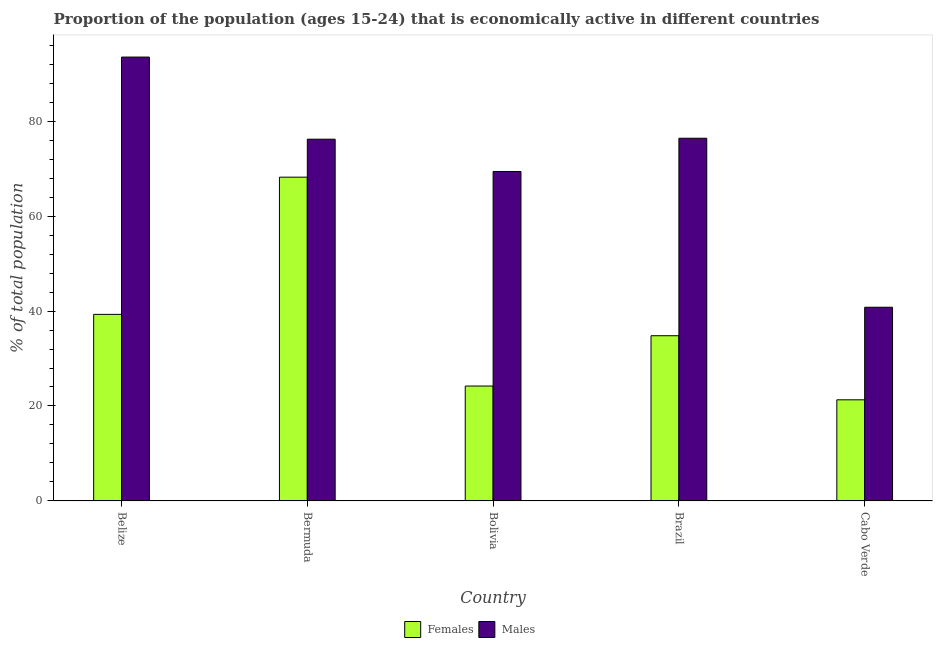What is the label of the 3rd group of bars from the left?
Your answer should be compact. Bolivia. In how many cases, is the number of bars for a given country not equal to the number of legend labels?
Give a very brief answer. 0. What is the percentage of economically active female population in Bermuda?
Make the answer very short. 68.2. Across all countries, what is the maximum percentage of economically active male population?
Make the answer very short. 93.5. Across all countries, what is the minimum percentage of economically active female population?
Make the answer very short. 21.3. In which country was the percentage of economically active female population maximum?
Offer a very short reply. Bermuda. In which country was the percentage of economically active female population minimum?
Your response must be concise. Cabo Verde. What is the total percentage of economically active female population in the graph?
Provide a short and direct response. 187.8. What is the difference between the percentage of economically active female population in Bolivia and the percentage of economically active male population in Belize?
Your answer should be compact. -69.3. What is the average percentage of economically active female population per country?
Offer a terse response. 37.56. What is the difference between the percentage of economically active female population and percentage of economically active male population in Belize?
Offer a terse response. -54.2. What is the ratio of the percentage of economically active female population in Belize to that in Cabo Verde?
Ensure brevity in your answer.  1.85. Is the percentage of economically active male population in Bolivia less than that in Brazil?
Keep it short and to the point. Yes. Is the difference between the percentage of economically active female population in Bolivia and Brazil greater than the difference between the percentage of economically active male population in Bolivia and Brazil?
Keep it short and to the point. No. What is the difference between the highest and the second highest percentage of economically active female population?
Your answer should be compact. 28.9. What is the difference between the highest and the lowest percentage of economically active male population?
Provide a succinct answer. 52.7. Is the sum of the percentage of economically active male population in Bolivia and Cabo Verde greater than the maximum percentage of economically active female population across all countries?
Your answer should be compact. Yes. What does the 1st bar from the left in Brazil represents?
Keep it short and to the point. Females. What does the 2nd bar from the right in Brazil represents?
Keep it short and to the point. Females. How many bars are there?
Make the answer very short. 10. What is the difference between two consecutive major ticks on the Y-axis?
Keep it short and to the point. 20. How many legend labels are there?
Provide a succinct answer. 2. What is the title of the graph?
Your response must be concise. Proportion of the population (ages 15-24) that is economically active in different countries. What is the label or title of the X-axis?
Give a very brief answer. Country. What is the label or title of the Y-axis?
Provide a succinct answer. % of total population. What is the % of total population in Females in Belize?
Your answer should be very brief. 39.3. What is the % of total population of Males in Belize?
Give a very brief answer. 93.5. What is the % of total population in Females in Bermuda?
Make the answer very short. 68.2. What is the % of total population in Males in Bermuda?
Provide a short and direct response. 76.2. What is the % of total population of Females in Bolivia?
Provide a succinct answer. 24.2. What is the % of total population of Males in Bolivia?
Offer a terse response. 69.4. What is the % of total population in Females in Brazil?
Ensure brevity in your answer.  34.8. What is the % of total population of Males in Brazil?
Provide a succinct answer. 76.4. What is the % of total population in Females in Cabo Verde?
Ensure brevity in your answer.  21.3. What is the % of total population in Males in Cabo Verde?
Ensure brevity in your answer.  40.8. Across all countries, what is the maximum % of total population in Females?
Make the answer very short. 68.2. Across all countries, what is the maximum % of total population of Males?
Your response must be concise. 93.5. Across all countries, what is the minimum % of total population in Females?
Your answer should be very brief. 21.3. Across all countries, what is the minimum % of total population in Males?
Make the answer very short. 40.8. What is the total % of total population in Females in the graph?
Keep it short and to the point. 187.8. What is the total % of total population in Males in the graph?
Give a very brief answer. 356.3. What is the difference between the % of total population in Females in Belize and that in Bermuda?
Keep it short and to the point. -28.9. What is the difference between the % of total population in Females in Belize and that in Bolivia?
Your response must be concise. 15.1. What is the difference between the % of total population of Males in Belize and that in Bolivia?
Offer a very short reply. 24.1. What is the difference between the % of total population in Males in Belize and that in Brazil?
Your response must be concise. 17.1. What is the difference between the % of total population of Females in Belize and that in Cabo Verde?
Your answer should be very brief. 18. What is the difference between the % of total population of Males in Belize and that in Cabo Verde?
Keep it short and to the point. 52.7. What is the difference between the % of total population in Females in Bermuda and that in Brazil?
Provide a succinct answer. 33.4. What is the difference between the % of total population of Males in Bermuda and that in Brazil?
Make the answer very short. -0.2. What is the difference between the % of total population of Females in Bermuda and that in Cabo Verde?
Your answer should be compact. 46.9. What is the difference between the % of total population of Males in Bermuda and that in Cabo Verde?
Give a very brief answer. 35.4. What is the difference between the % of total population of Males in Bolivia and that in Brazil?
Keep it short and to the point. -7. What is the difference between the % of total population of Males in Bolivia and that in Cabo Verde?
Give a very brief answer. 28.6. What is the difference between the % of total population of Females in Brazil and that in Cabo Verde?
Give a very brief answer. 13.5. What is the difference between the % of total population of Males in Brazil and that in Cabo Verde?
Offer a very short reply. 35.6. What is the difference between the % of total population of Females in Belize and the % of total population of Males in Bermuda?
Give a very brief answer. -36.9. What is the difference between the % of total population in Females in Belize and the % of total population in Males in Bolivia?
Offer a very short reply. -30.1. What is the difference between the % of total population in Females in Belize and the % of total population in Males in Brazil?
Give a very brief answer. -37.1. What is the difference between the % of total population in Females in Belize and the % of total population in Males in Cabo Verde?
Your answer should be very brief. -1.5. What is the difference between the % of total population of Females in Bermuda and the % of total population of Males in Bolivia?
Your answer should be compact. -1.2. What is the difference between the % of total population in Females in Bermuda and the % of total population in Males in Brazil?
Your response must be concise. -8.2. What is the difference between the % of total population of Females in Bermuda and the % of total population of Males in Cabo Verde?
Provide a short and direct response. 27.4. What is the difference between the % of total population of Females in Bolivia and the % of total population of Males in Brazil?
Your response must be concise. -52.2. What is the difference between the % of total population in Females in Bolivia and the % of total population in Males in Cabo Verde?
Offer a terse response. -16.6. What is the average % of total population of Females per country?
Your answer should be compact. 37.56. What is the average % of total population in Males per country?
Offer a very short reply. 71.26. What is the difference between the % of total population of Females and % of total population of Males in Belize?
Offer a very short reply. -54.2. What is the difference between the % of total population of Females and % of total population of Males in Bolivia?
Offer a very short reply. -45.2. What is the difference between the % of total population of Females and % of total population of Males in Brazil?
Make the answer very short. -41.6. What is the difference between the % of total population in Females and % of total population in Males in Cabo Verde?
Ensure brevity in your answer.  -19.5. What is the ratio of the % of total population of Females in Belize to that in Bermuda?
Provide a succinct answer. 0.58. What is the ratio of the % of total population of Males in Belize to that in Bermuda?
Give a very brief answer. 1.23. What is the ratio of the % of total population of Females in Belize to that in Bolivia?
Provide a succinct answer. 1.62. What is the ratio of the % of total population in Males in Belize to that in Bolivia?
Offer a very short reply. 1.35. What is the ratio of the % of total population in Females in Belize to that in Brazil?
Provide a short and direct response. 1.13. What is the ratio of the % of total population of Males in Belize to that in Brazil?
Your answer should be compact. 1.22. What is the ratio of the % of total population of Females in Belize to that in Cabo Verde?
Make the answer very short. 1.85. What is the ratio of the % of total population in Males in Belize to that in Cabo Verde?
Provide a short and direct response. 2.29. What is the ratio of the % of total population of Females in Bermuda to that in Bolivia?
Keep it short and to the point. 2.82. What is the ratio of the % of total population in Males in Bermuda to that in Bolivia?
Your answer should be compact. 1.1. What is the ratio of the % of total population of Females in Bermuda to that in Brazil?
Offer a very short reply. 1.96. What is the ratio of the % of total population in Females in Bermuda to that in Cabo Verde?
Keep it short and to the point. 3.2. What is the ratio of the % of total population of Males in Bermuda to that in Cabo Verde?
Offer a terse response. 1.87. What is the ratio of the % of total population of Females in Bolivia to that in Brazil?
Provide a succinct answer. 0.7. What is the ratio of the % of total population of Males in Bolivia to that in Brazil?
Offer a very short reply. 0.91. What is the ratio of the % of total population of Females in Bolivia to that in Cabo Verde?
Ensure brevity in your answer.  1.14. What is the ratio of the % of total population in Males in Bolivia to that in Cabo Verde?
Provide a short and direct response. 1.7. What is the ratio of the % of total population in Females in Brazil to that in Cabo Verde?
Offer a very short reply. 1.63. What is the ratio of the % of total population in Males in Brazil to that in Cabo Verde?
Your answer should be very brief. 1.87. What is the difference between the highest and the second highest % of total population in Females?
Provide a succinct answer. 28.9. What is the difference between the highest and the second highest % of total population in Males?
Ensure brevity in your answer.  17.1. What is the difference between the highest and the lowest % of total population of Females?
Offer a very short reply. 46.9. What is the difference between the highest and the lowest % of total population of Males?
Your answer should be compact. 52.7. 